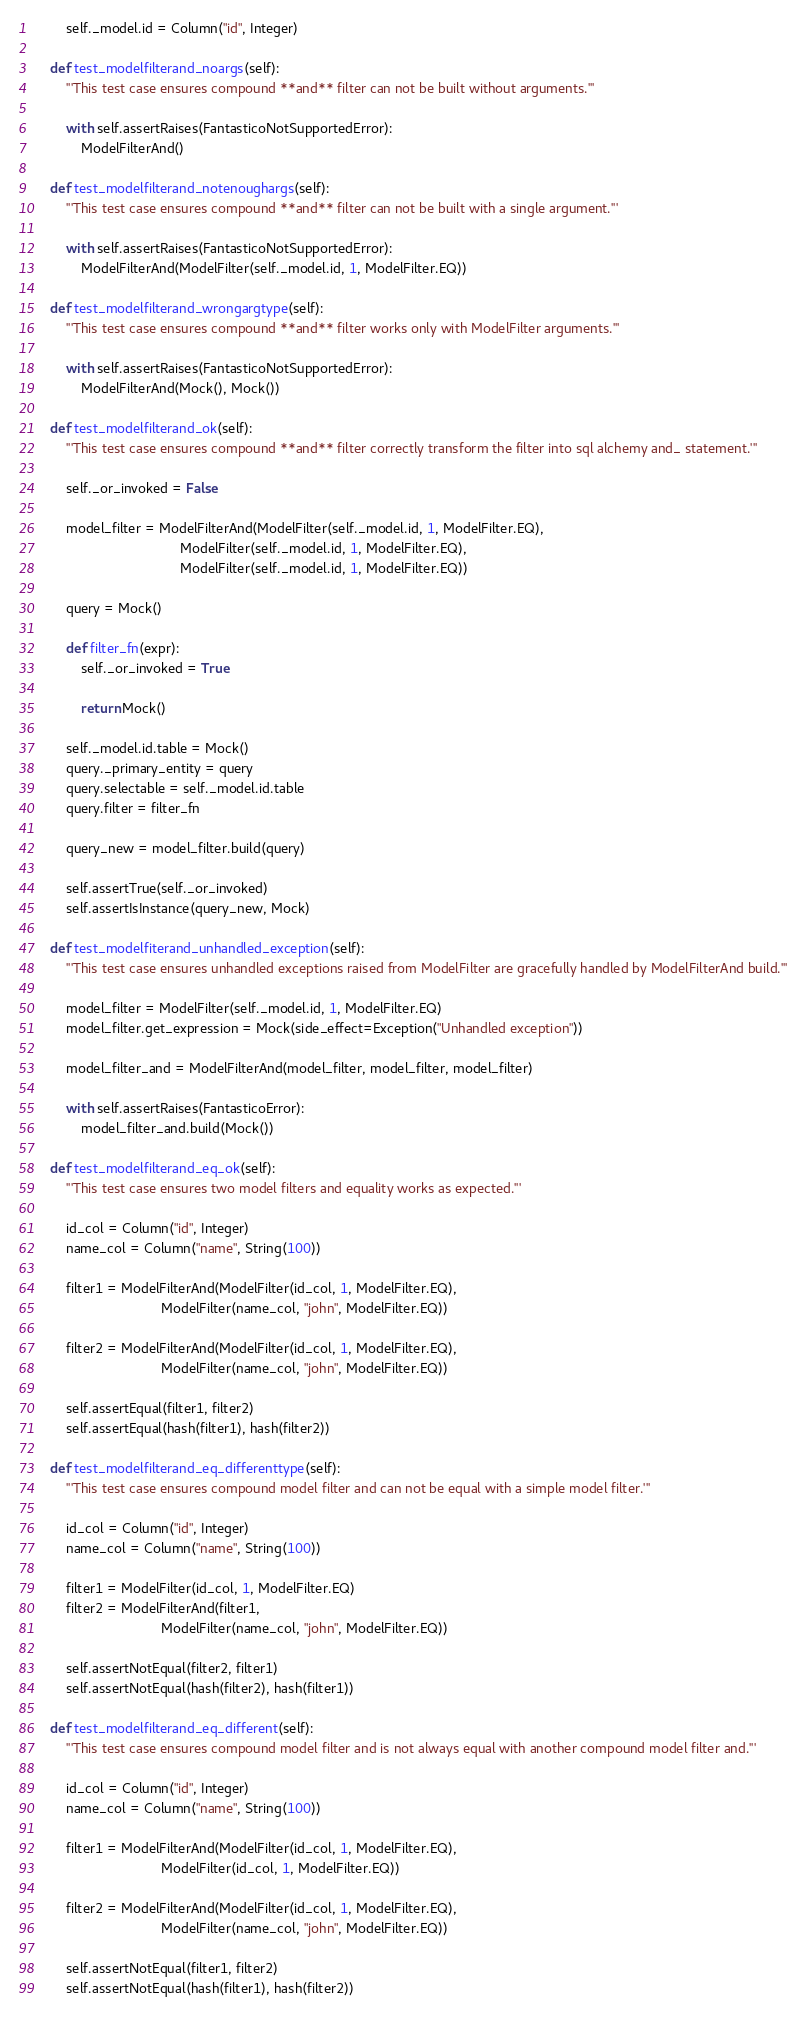Convert code to text. <code><loc_0><loc_0><loc_500><loc_500><_Python_>        self._model.id = Column("id", Integer)

    def test_modelfilterand_noargs(self):
        '''This test case ensures compound **and** filter can not be built without arguments.'''

        with self.assertRaises(FantasticoNotSupportedError):
            ModelFilterAnd()

    def test_modelfilterand_notenoughargs(self):
        '''This test case ensures compound **and** filter can not be built with a single argument.'''

        with self.assertRaises(FantasticoNotSupportedError):
            ModelFilterAnd(ModelFilter(self._model.id, 1, ModelFilter.EQ))

    def test_modelfilterand_wrongargtype(self):
        '''This test case ensures compound **and** filter works only with ModelFilter arguments.'''

        with self.assertRaises(FantasticoNotSupportedError):
            ModelFilterAnd(Mock(), Mock())

    def test_modelfilterand_ok(self):
        '''This test case ensures compound **and** filter correctly transform the filter into sql alchemy and_ statement.'''

        self._or_invoked = False

        model_filter = ModelFilterAnd(ModelFilter(self._model.id, 1, ModelFilter.EQ),
                                      ModelFilter(self._model.id, 1, ModelFilter.EQ),
                                      ModelFilter(self._model.id, 1, ModelFilter.EQ))

        query = Mock()

        def filter_fn(expr):
            self._or_invoked = True

            return Mock()

        self._model.id.table = Mock()
        query._primary_entity = query
        query.selectable = self._model.id.table
        query.filter = filter_fn

        query_new = model_filter.build(query)

        self.assertTrue(self._or_invoked)
        self.assertIsInstance(query_new, Mock)

    def test_modelfiterand_unhandled_exception(self):
        '''This test case ensures unhandled exceptions raised from ModelFilter are gracefully handled by ModelFilterAnd build.'''

        model_filter = ModelFilter(self._model.id, 1, ModelFilter.EQ)
        model_filter.get_expression = Mock(side_effect=Exception("Unhandled exception"))

        model_filter_and = ModelFilterAnd(model_filter, model_filter, model_filter)

        with self.assertRaises(FantasticoError):
            model_filter_and.build(Mock())

    def test_modelfilterand_eq_ok(self):
        '''This test case ensures two model filters and equality works as expected.'''

        id_col = Column("id", Integer)
        name_col = Column("name", String(100))

        filter1 = ModelFilterAnd(ModelFilter(id_col, 1, ModelFilter.EQ),
                                 ModelFilter(name_col, "john", ModelFilter.EQ))

        filter2 = ModelFilterAnd(ModelFilter(id_col, 1, ModelFilter.EQ),
                                 ModelFilter(name_col, "john", ModelFilter.EQ))

        self.assertEqual(filter1, filter2)
        self.assertEqual(hash(filter1), hash(filter2))

    def test_modelfilterand_eq_differenttype(self):
        '''This test case ensures compound model filter and can not be equal with a simple model filter.'''

        id_col = Column("id", Integer)
        name_col = Column("name", String(100))

        filter1 = ModelFilter(id_col, 1, ModelFilter.EQ)
        filter2 = ModelFilterAnd(filter1,
                                 ModelFilter(name_col, "john", ModelFilter.EQ))

        self.assertNotEqual(filter2, filter1)
        self.assertNotEqual(hash(filter2), hash(filter1))

    def test_modelfilterand_eq_different(self):
        '''This test case ensures compound model filter and is not always equal with another compound model filter and.'''

        id_col = Column("id", Integer)
        name_col = Column("name", String(100))

        filter1 = ModelFilterAnd(ModelFilter(id_col, 1, ModelFilter.EQ),
                                 ModelFilter(id_col, 1, ModelFilter.EQ))

        filter2 = ModelFilterAnd(ModelFilter(id_col, 1, ModelFilter.EQ),
                                 ModelFilter(name_col, "john", ModelFilter.EQ))

        self.assertNotEqual(filter1, filter2)
        self.assertNotEqual(hash(filter1), hash(filter2))
</code> 